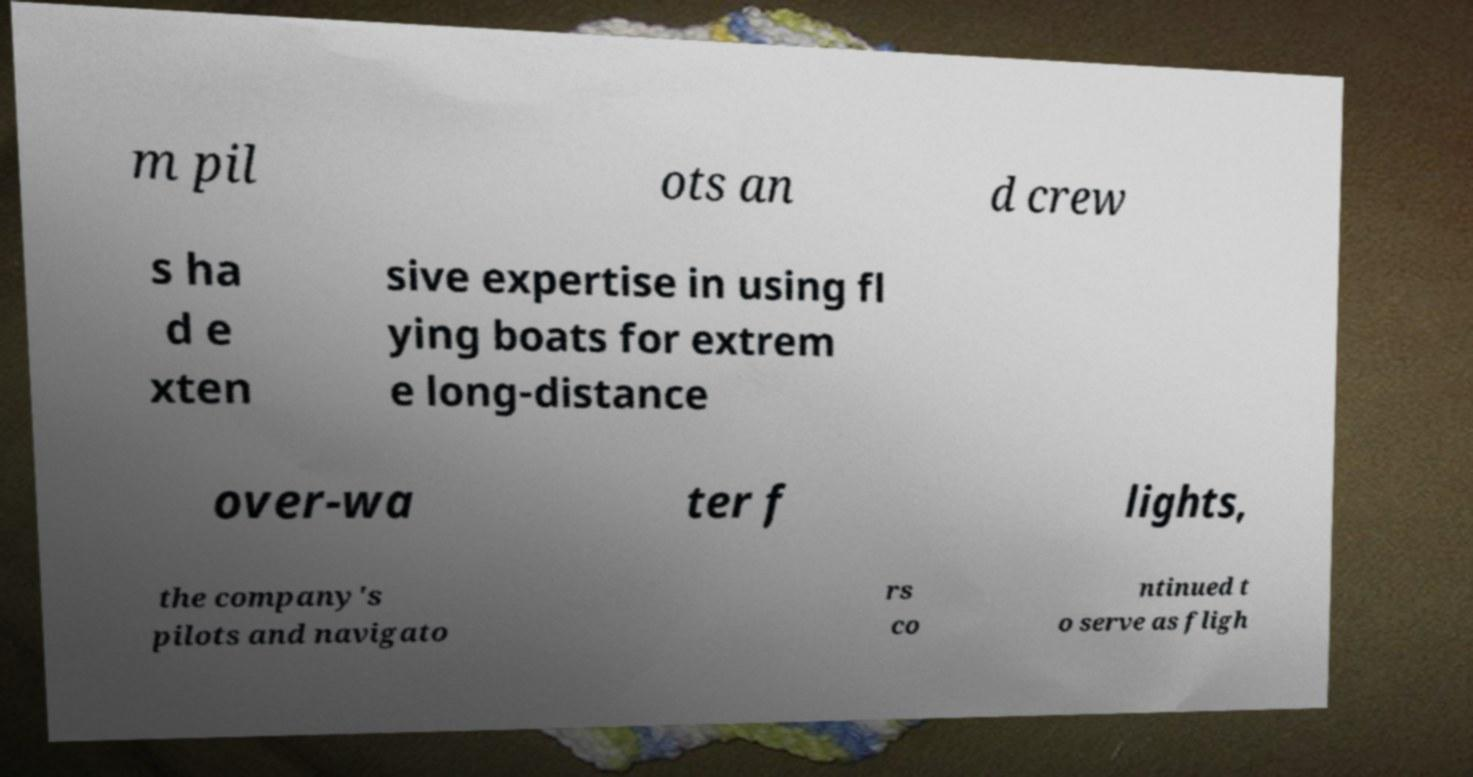Please read and relay the text visible in this image. What does it say? m pil ots an d crew s ha d e xten sive expertise in using fl ying boats for extrem e long-distance over-wa ter f lights, the company's pilots and navigato rs co ntinued t o serve as fligh 